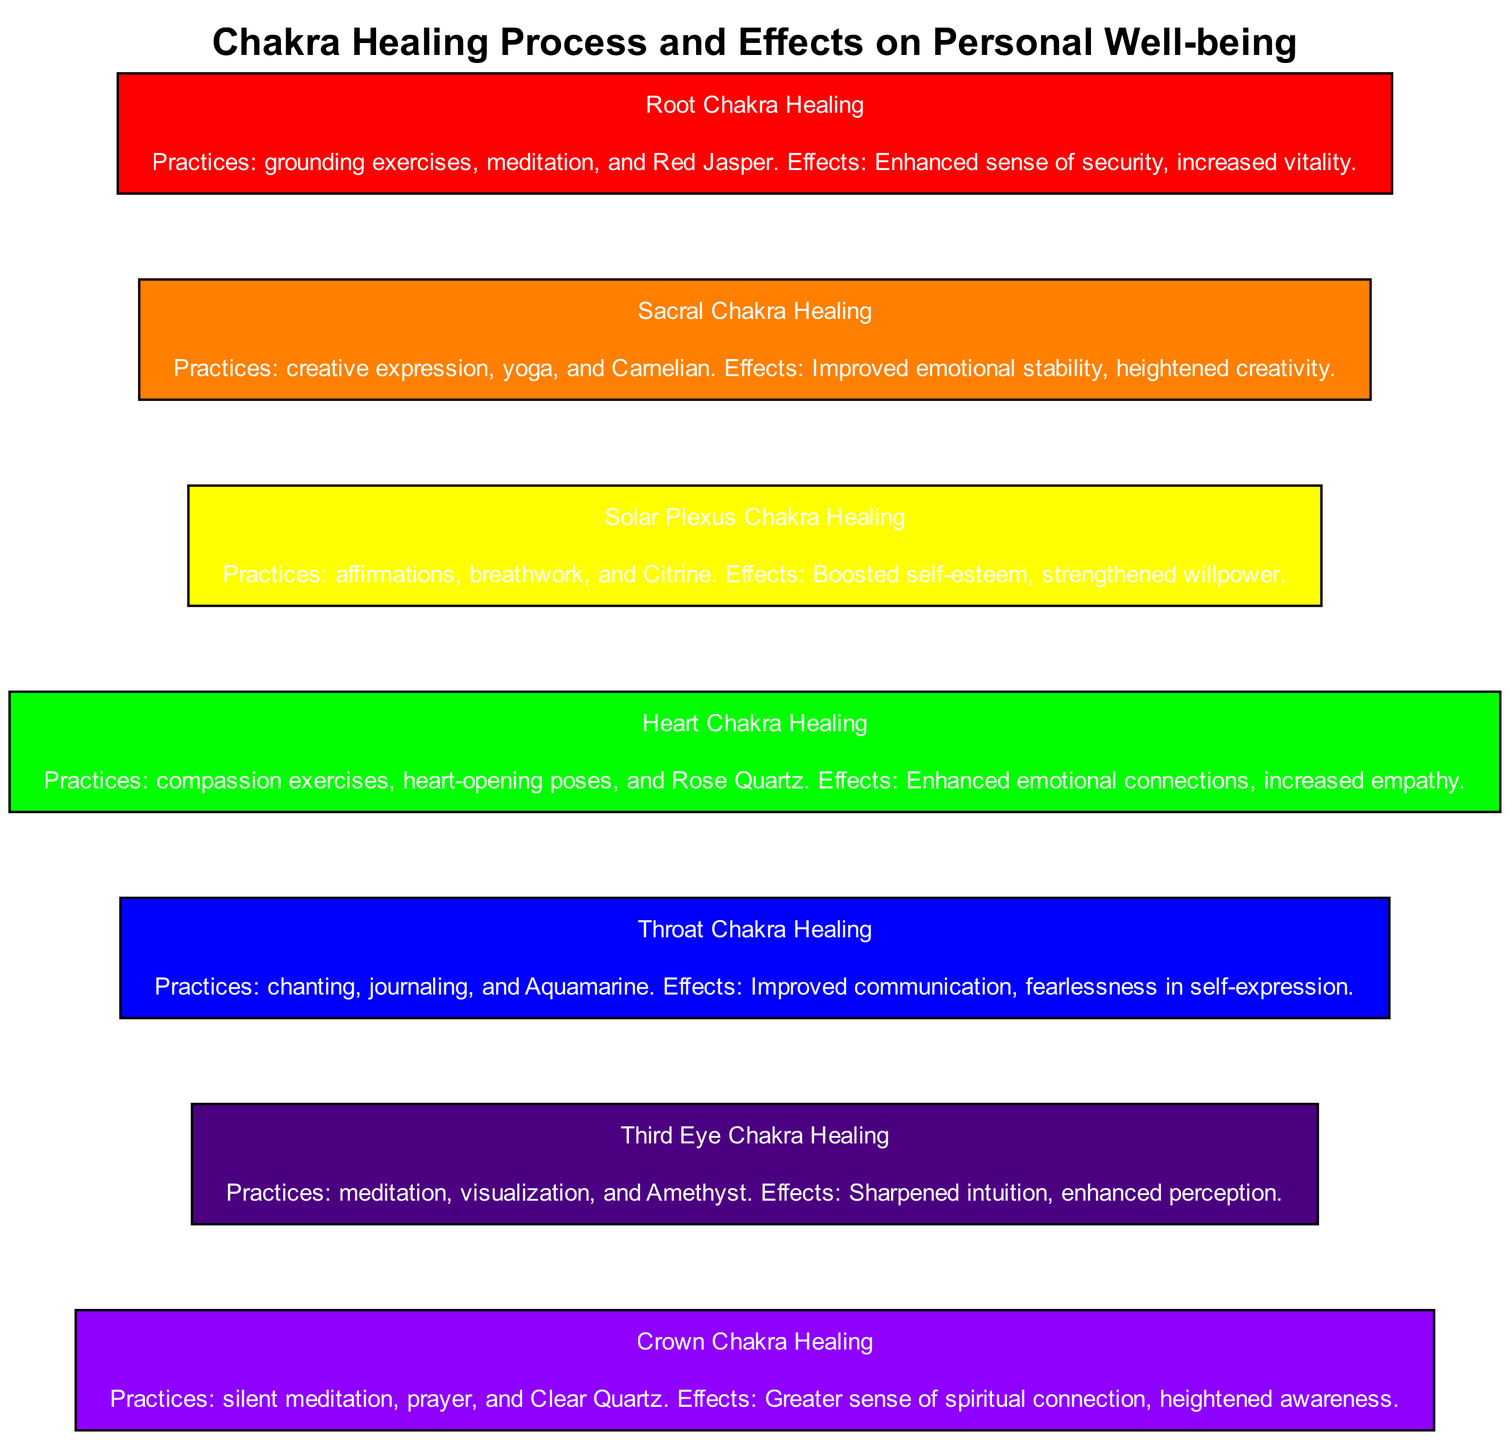What is the first chakra healing type shown in the diagram? The first chakra healing type is indicated as "Root Chakra Healing," which is positioned at the top of the block diagram.
Answer: Root Chakra Healing How many chakra healing types are represented in the diagram? The diagram includes a total of seven chakra healing types, as each block corresponds to a specific chakra.
Answer: 7 What practice is associated with the Solar Plexus Chakra Healing? The practice listed under Solar Plexus Chakra Healing is "affirmations," which is one of the approaches mentioned in the description of that chakra healing type.
Answer: affirmations What effect does Heart Chakra Healing promote? The description for Heart Chakra Healing states that it enhances emotional connections, thus that is the effect associated with it.
Answer: Enhanced emotional connections Which chakra healing type includes the use of Amethyst? The Third Eye Chakra Healing includes the use of Amethyst, as mentioned in the practices for that specific chakra.
Answer: Third Eye Chakra Healing What is the last chakra healing type in the diagram? The last chakra healing type noted in the block diagram is "Crown Chakra Healing," positioned at the bottom, indicating its sequence in the hierarchy of the chakras.
Answer: Crown Chakra Healing What color is associated with the Throat Chakra Healing? The Throat Chakra Healing block is colored with a specific shade that corresponds to its chakra color, which is blue.
Answer: blue Which chakra healing involves grounding exercises? Grounding exercises are specifically linked to the Root Chakra Healing, as described in its practices.
Answer: Root Chakra Healing 